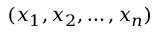Convert formula to latex. <formula><loc_0><loc_0><loc_500><loc_500>( x _ { 1 } , x _ { 2 } , \dots c , x _ { n } )</formula> 